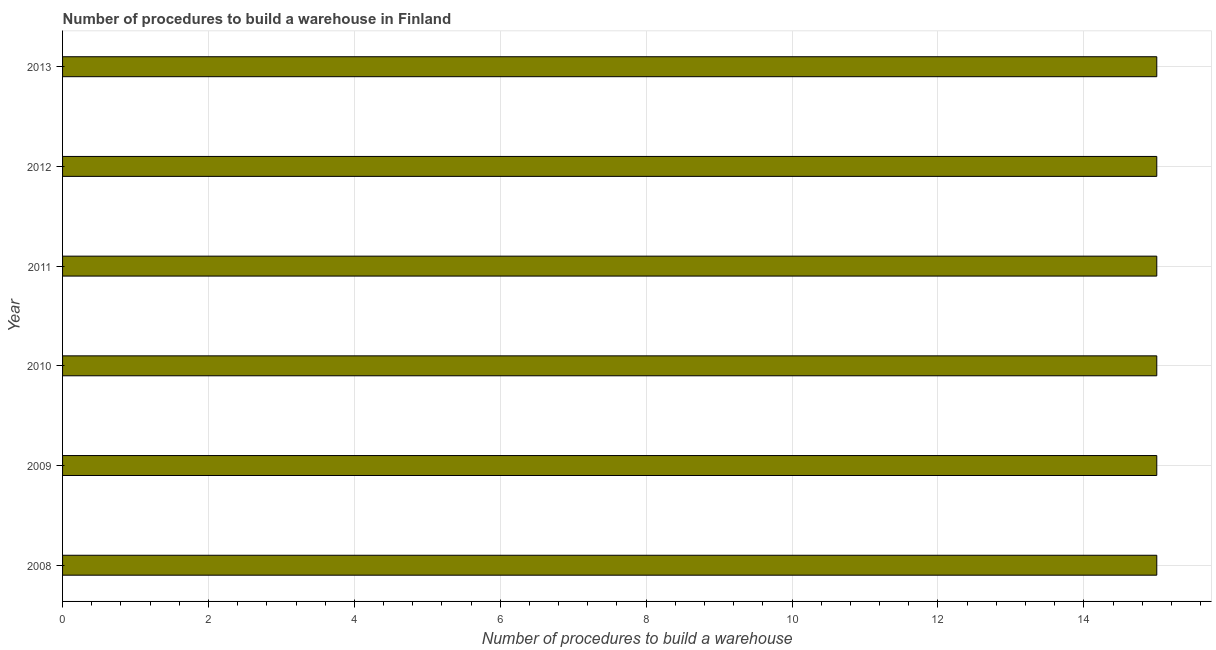What is the title of the graph?
Ensure brevity in your answer.  Number of procedures to build a warehouse in Finland. What is the label or title of the X-axis?
Provide a succinct answer. Number of procedures to build a warehouse. What is the label or title of the Y-axis?
Give a very brief answer. Year. Across all years, what is the minimum number of procedures to build a warehouse?
Your response must be concise. 15. In which year was the number of procedures to build a warehouse maximum?
Your answer should be very brief. 2008. What is the difference between the number of procedures to build a warehouse in 2010 and 2011?
Ensure brevity in your answer.  0. What is the average number of procedures to build a warehouse per year?
Give a very brief answer. 15. In how many years, is the number of procedures to build a warehouse greater than 12.8 ?
Provide a short and direct response. 6. What is the ratio of the number of procedures to build a warehouse in 2008 to that in 2012?
Offer a terse response. 1. What is the difference between the highest and the second highest number of procedures to build a warehouse?
Offer a very short reply. 0. How many bars are there?
Offer a terse response. 6. How many years are there in the graph?
Give a very brief answer. 6. What is the Number of procedures to build a warehouse of 2008?
Keep it short and to the point. 15. What is the Number of procedures to build a warehouse of 2011?
Your response must be concise. 15. What is the Number of procedures to build a warehouse in 2012?
Offer a very short reply. 15. What is the Number of procedures to build a warehouse of 2013?
Ensure brevity in your answer.  15. What is the difference between the Number of procedures to build a warehouse in 2008 and 2009?
Your answer should be very brief. 0. What is the difference between the Number of procedures to build a warehouse in 2008 and 2010?
Give a very brief answer. 0. What is the difference between the Number of procedures to build a warehouse in 2008 and 2011?
Keep it short and to the point. 0. What is the difference between the Number of procedures to build a warehouse in 2008 and 2012?
Your answer should be very brief. 0. What is the difference between the Number of procedures to build a warehouse in 2008 and 2013?
Your answer should be very brief. 0. What is the difference between the Number of procedures to build a warehouse in 2009 and 2010?
Your answer should be very brief. 0. What is the difference between the Number of procedures to build a warehouse in 2009 and 2012?
Provide a succinct answer. 0. What is the difference between the Number of procedures to build a warehouse in 2009 and 2013?
Give a very brief answer. 0. What is the difference between the Number of procedures to build a warehouse in 2010 and 2012?
Keep it short and to the point. 0. What is the difference between the Number of procedures to build a warehouse in 2010 and 2013?
Provide a succinct answer. 0. What is the difference between the Number of procedures to build a warehouse in 2012 and 2013?
Your answer should be compact. 0. What is the ratio of the Number of procedures to build a warehouse in 2009 to that in 2012?
Make the answer very short. 1. What is the ratio of the Number of procedures to build a warehouse in 2009 to that in 2013?
Provide a succinct answer. 1. What is the ratio of the Number of procedures to build a warehouse in 2010 to that in 2013?
Give a very brief answer. 1. What is the ratio of the Number of procedures to build a warehouse in 2012 to that in 2013?
Keep it short and to the point. 1. 